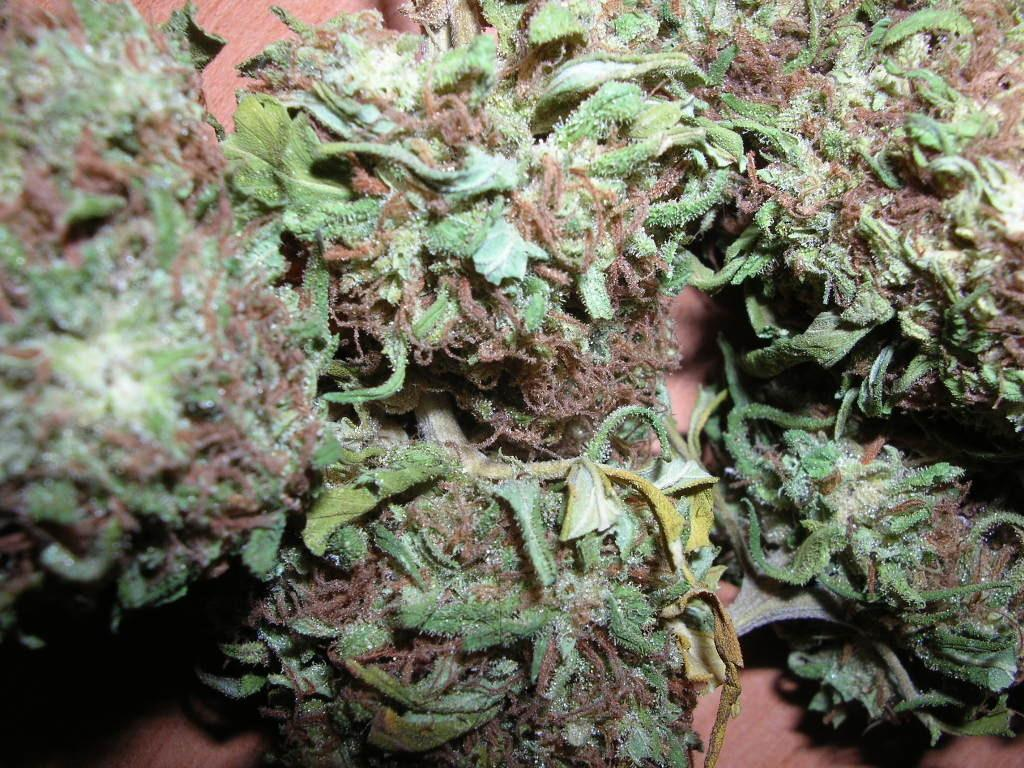What type of strain is depicted in the image? There is a dirty harry strain in the image. What is the color of the table on which the strain is placed? The strain is placed on a brown color table. What type of music can be heard playing in the background of the image? There is no music present in the image, as it only shows a dirty harry strain on a brown table. 